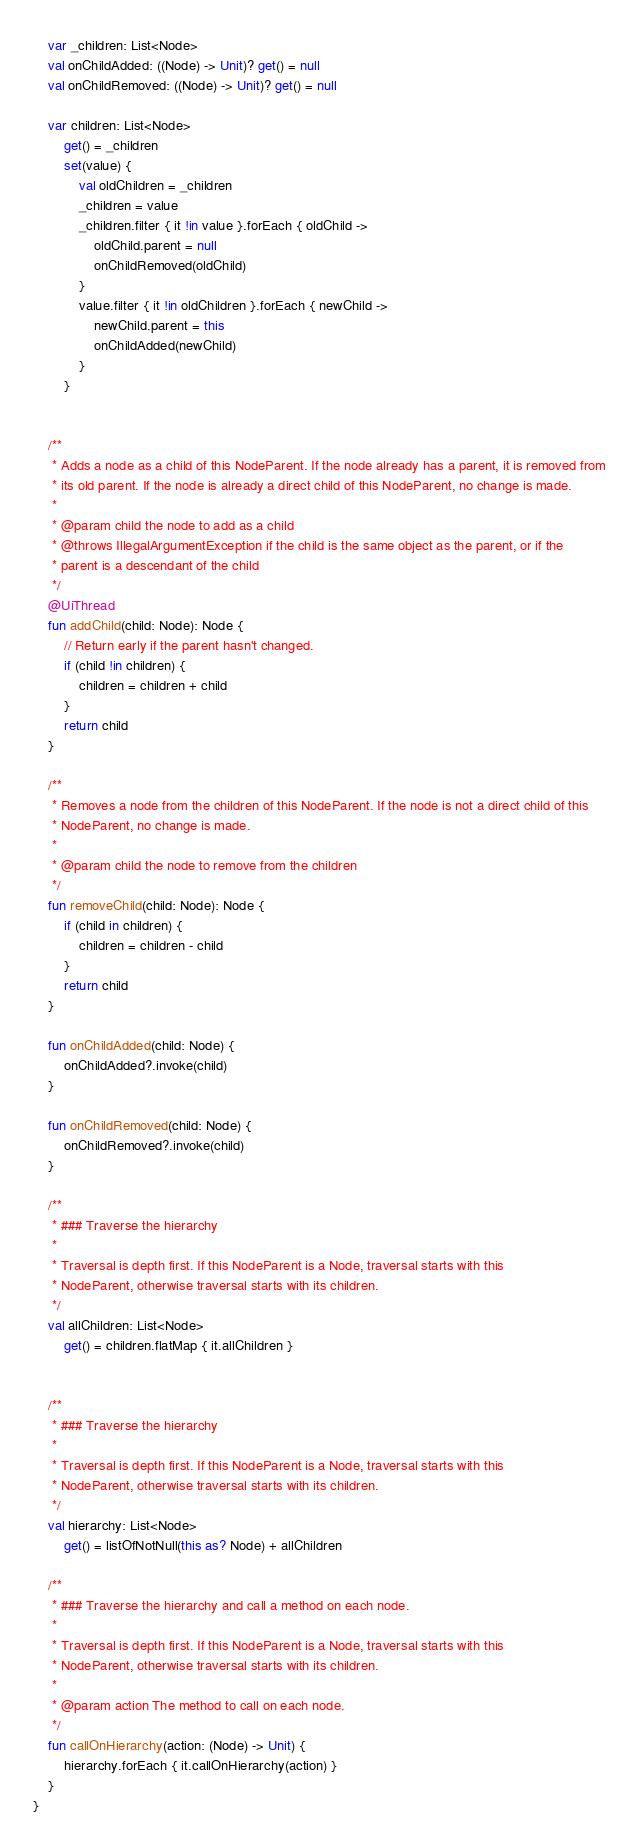Convert code to text. <code><loc_0><loc_0><loc_500><loc_500><_Kotlin_>    var _children: List<Node>
    val onChildAdded: ((Node) -> Unit)? get() = null
    val onChildRemoved: ((Node) -> Unit)? get() = null

    var children: List<Node>
        get() = _children
        set(value) {
            val oldChildren = _children
            _children = value
            _children.filter { it !in value }.forEach { oldChild ->
                oldChild.parent = null
                onChildRemoved(oldChild)
            }
            value.filter { it !in oldChildren }.forEach { newChild ->
                newChild.parent = this
                onChildAdded(newChild)
            }
        }


    /**
     * Adds a node as a child of this NodeParent. If the node already has a parent, it is removed from
     * its old parent. If the node is already a direct child of this NodeParent, no change is made.
     *
     * @param child the node to add as a child
     * @throws IllegalArgumentException if the child is the same object as the parent, or if the
     * parent is a descendant of the child
     */
    @UiThread
    fun addChild(child: Node): Node {
        // Return early if the parent hasn't changed.
        if (child !in children) {
            children = children + child
        }
        return child
    }

    /**
     * Removes a node from the children of this NodeParent. If the node is not a direct child of this
     * NodeParent, no change is made.
     *
     * @param child the node to remove from the children
     */
    fun removeChild(child: Node): Node {
        if (child in children) {
            children = children - child
        }
        return child
    }

    fun onChildAdded(child: Node) {
        onChildAdded?.invoke(child)
    }

    fun onChildRemoved(child: Node) {
        onChildRemoved?.invoke(child)
    }

    /**
     * ### Traverse the hierarchy
     *
     * Traversal is depth first. If this NodeParent is a Node, traversal starts with this
     * NodeParent, otherwise traversal starts with its children.
     */
    val allChildren: List<Node>
        get() = children.flatMap { it.allChildren }


    /**
     * ### Traverse the hierarchy
     *
     * Traversal is depth first. If this NodeParent is a Node, traversal starts with this
     * NodeParent, otherwise traversal starts with its children.
     */
    val hierarchy: List<Node>
        get() = listOfNotNull(this as? Node) + allChildren

    /**
     * ### Traverse the hierarchy and call a method on each node.
     *
     * Traversal is depth first. If this NodeParent is a Node, traversal starts with this
     * NodeParent, otherwise traversal starts with its children.
     *
     * @param action The method to call on each node.
     */
    fun callOnHierarchy(action: (Node) -> Unit) {
        hierarchy.forEach { it.callOnHierarchy(action) }
    }
}</code> 